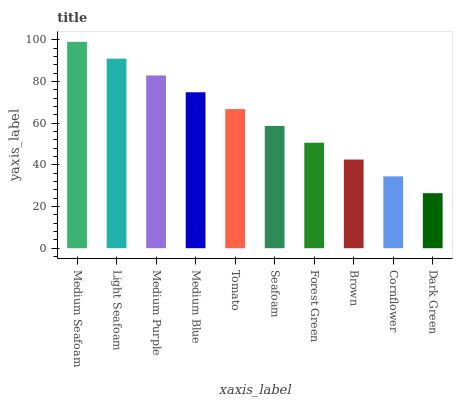Is Dark Green the minimum?
Answer yes or no. Yes. Is Medium Seafoam the maximum?
Answer yes or no. Yes. Is Light Seafoam the minimum?
Answer yes or no. No. Is Light Seafoam the maximum?
Answer yes or no. No. Is Medium Seafoam greater than Light Seafoam?
Answer yes or no. Yes. Is Light Seafoam less than Medium Seafoam?
Answer yes or no. Yes. Is Light Seafoam greater than Medium Seafoam?
Answer yes or no. No. Is Medium Seafoam less than Light Seafoam?
Answer yes or no. No. Is Tomato the high median?
Answer yes or no. Yes. Is Seafoam the low median?
Answer yes or no. Yes. Is Forest Green the high median?
Answer yes or no. No. Is Light Seafoam the low median?
Answer yes or no. No. 